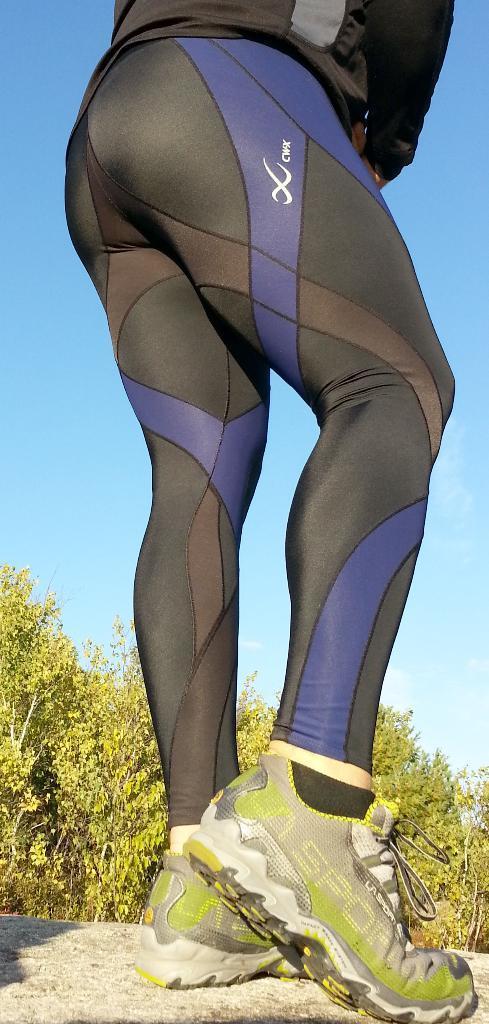Describe this image in one or two sentences. In this image in the front there is a person standing. In the background there are trees. 